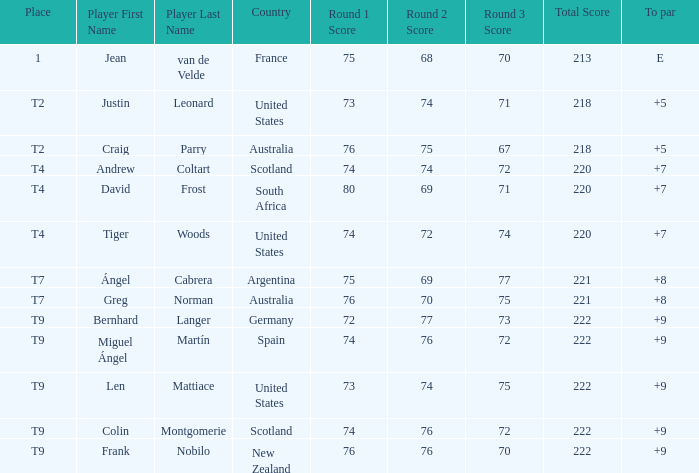What is the position number of craig parry from australia? T2. Help me parse the entirety of this table. {'header': ['Place', 'Player First Name', 'Player Last Name', 'Country', 'Round 1 Score', 'Round 2 Score', 'Round 3 Score', 'Total Score', 'To par'], 'rows': [['1', 'Jean', 'van de Velde', 'France', '75', '68', '70', '213', 'E'], ['T2', 'Justin', 'Leonard', 'United States', '73', '74', '71', '218', '+5'], ['T2', 'Craig', 'Parry', 'Australia', '76', '75', '67', '218', '+5'], ['T4', 'Andrew', 'Coltart', 'Scotland', '74', '74', '72', '220', '+7'], ['T4', 'David', 'Frost', 'South Africa', '80', '69', '71', '220', '+7'], ['T4', 'Tiger', 'Woods', 'United States', '74', '72', '74', '220', '+7'], ['T7', 'Ángel', 'Cabrera', 'Argentina', '75', '69', '77', '221', '+8'], ['T7', 'Greg', 'Norman', 'Australia', '76', '70', '75', '221', '+8'], ['T9', 'Bernhard', 'Langer', 'Germany', '72', '77', '73', '222', '+9'], ['T9', 'Miguel Ángel', 'Martín', 'Spain', '74', '76', '72', '222', '+9'], ['T9', 'Len', 'Mattiace', 'United States', '73', '74', '75', '222', '+9'], ['T9', 'Colin', 'Montgomerie', 'Scotland', '74', '76', '72', '222', '+9'], ['T9', 'Frank', 'Nobilo', 'New Zealand', '76', '76', '70', '222', '+9']]} 